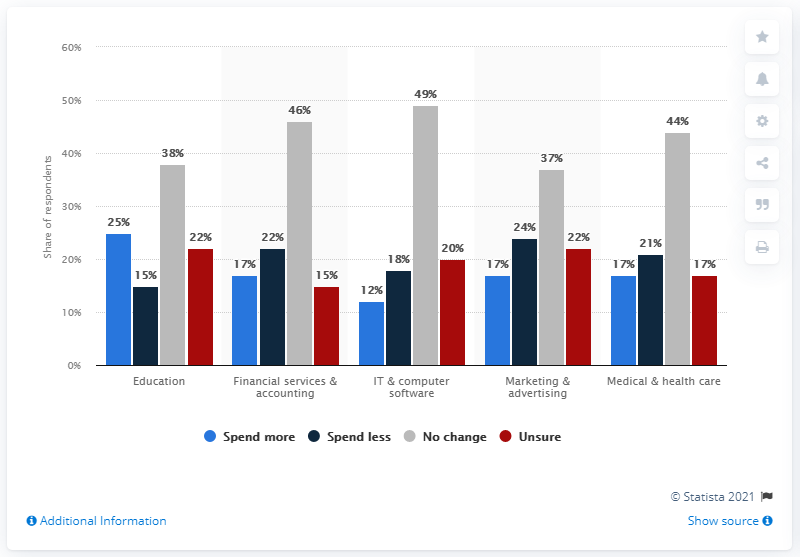List a handful of essential elements in this visual. The IT & computer software industry has the highest potential for significant spending impacts with little or no change. The average increase in spending for participants who spent more in the survey was 17.6%. 